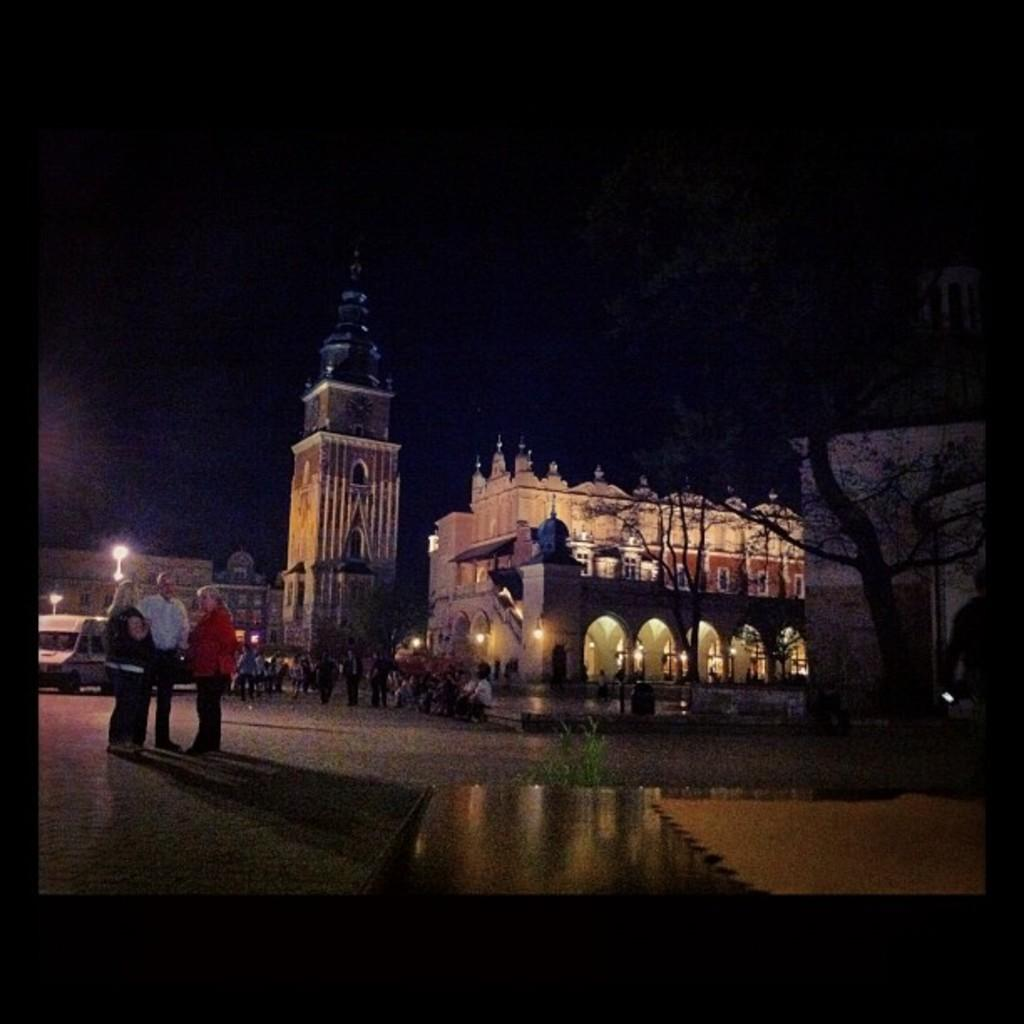Who or what can be seen in the image? There are people in the image. What is located on the right side of the image? There is a tree on the right side of the image. What can be seen in the distance in the image? There are buildings in the background of the image. Can you see a kitty wearing a veil in the image? No, there is no kitty or veil present in the image. What type of hall can be seen in the image? There is no hall depicted in the image; it features people, a tree, and buildings in the background. 